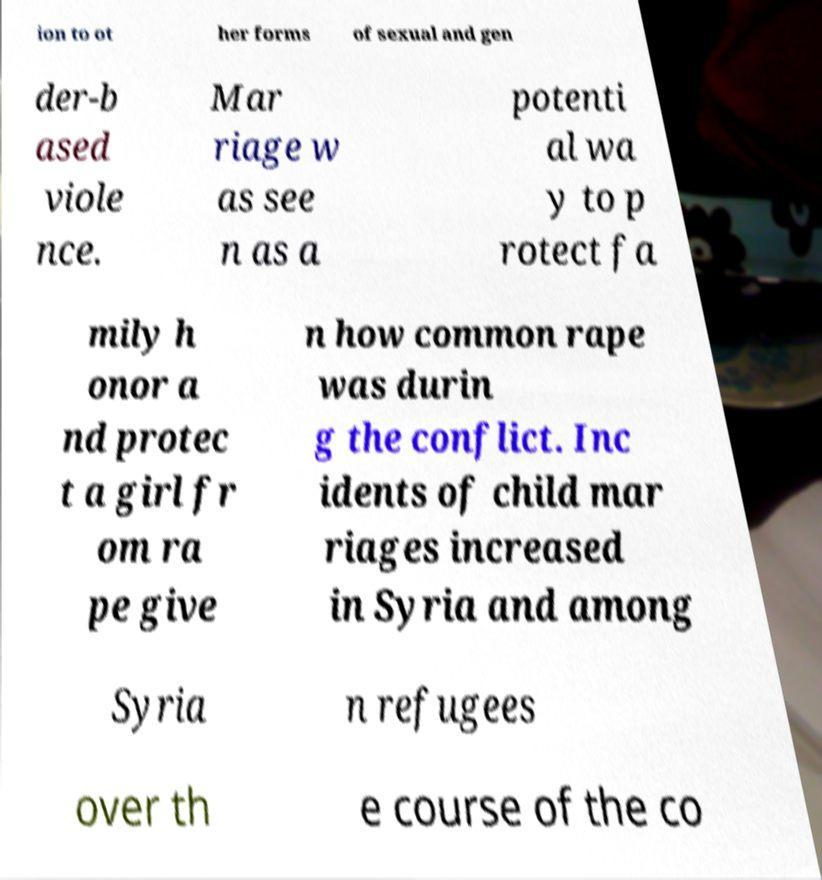For documentation purposes, I need the text within this image transcribed. Could you provide that? ion to ot her forms of sexual and gen der-b ased viole nce. Mar riage w as see n as a potenti al wa y to p rotect fa mily h onor a nd protec t a girl fr om ra pe give n how common rape was durin g the conflict. Inc idents of child mar riages increased in Syria and among Syria n refugees over th e course of the co 